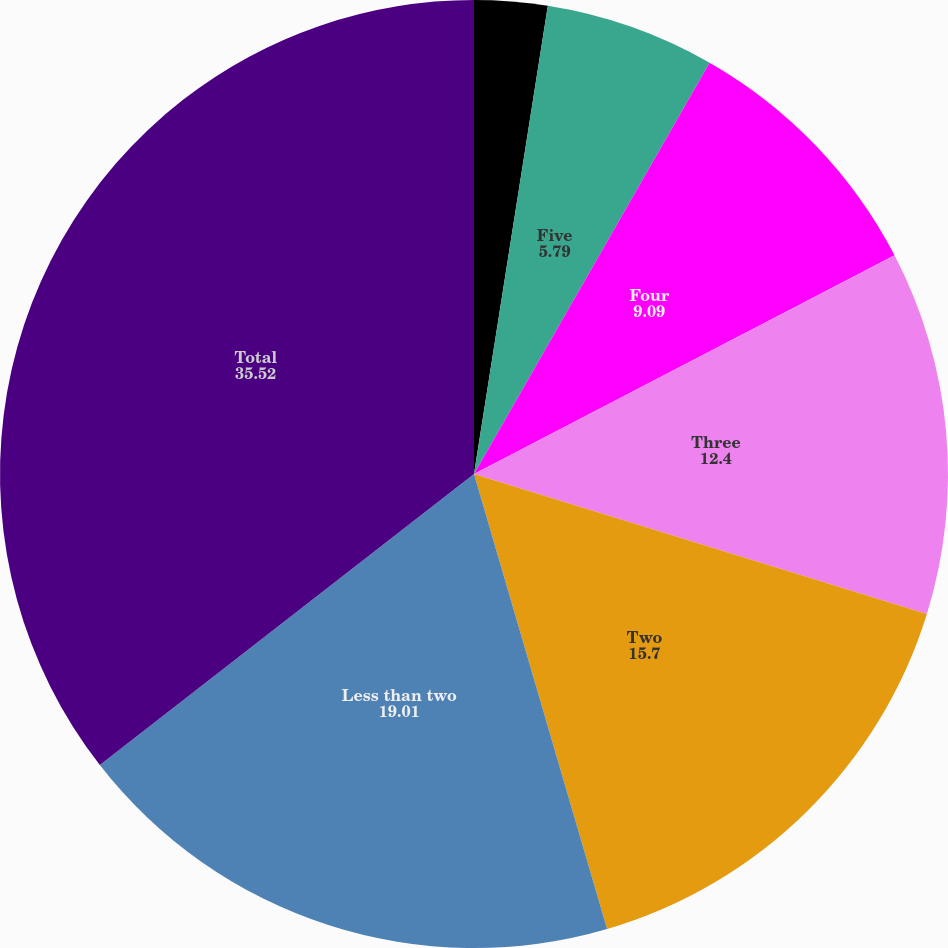Convert chart. <chart><loc_0><loc_0><loc_500><loc_500><pie_chart><fcel>Greater than five<fcel>Five<fcel>Four<fcel>Three<fcel>Two<fcel>Less than two<fcel>Total<nl><fcel>2.49%<fcel>5.79%<fcel>9.09%<fcel>12.4%<fcel>15.7%<fcel>19.01%<fcel>35.52%<nl></chart> 